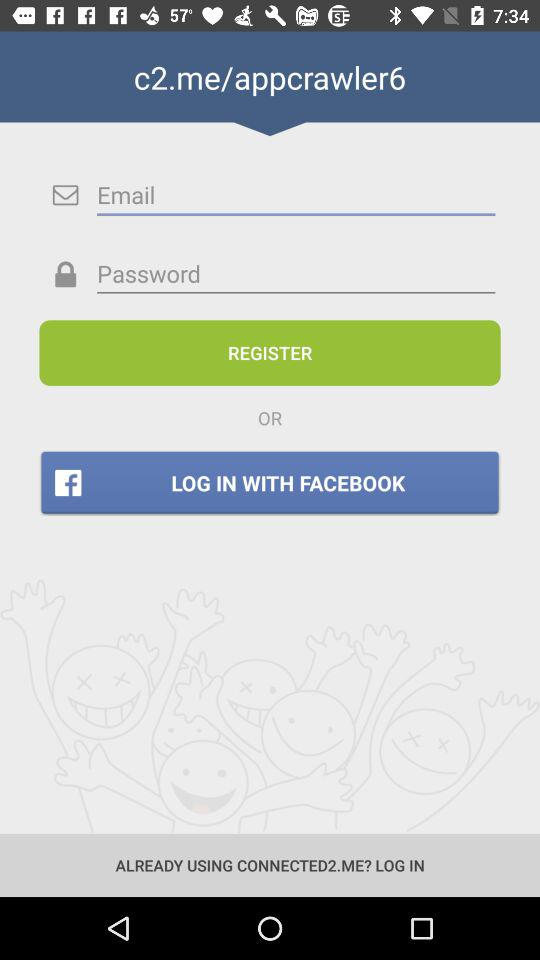How many text inputs are there for logging in?
Answer the question using a single word or phrase. 2 